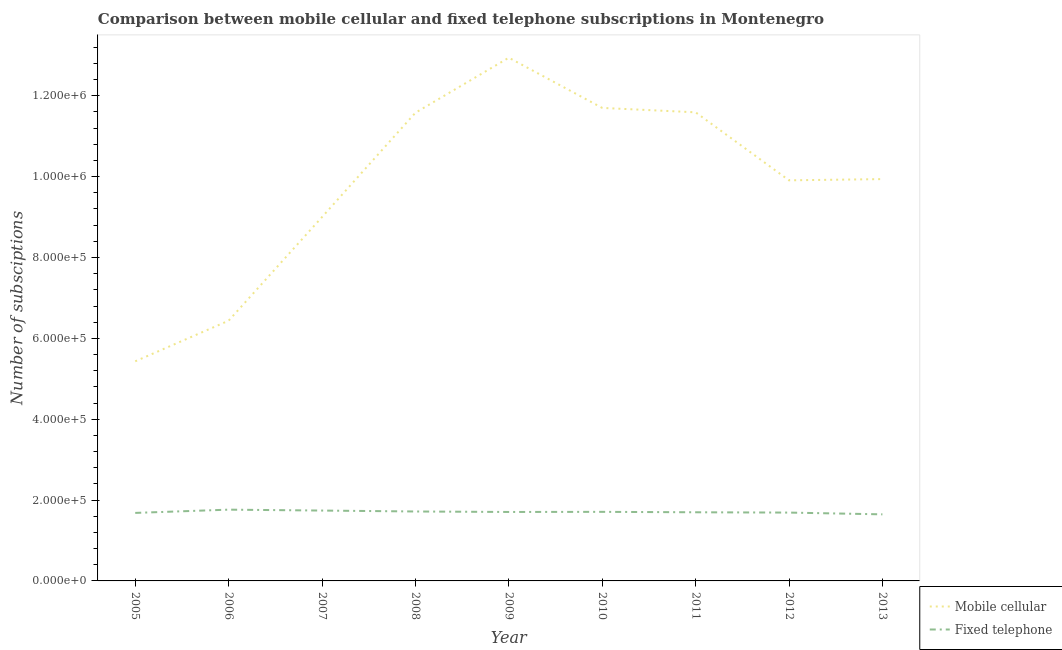What is the number of mobile cellular subscriptions in 2009?
Your answer should be very brief. 1.29e+06. Across all years, what is the maximum number of mobile cellular subscriptions?
Provide a short and direct response. 1.29e+06. Across all years, what is the minimum number of fixed telephone subscriptions?
Give a very brief answer. 1.65e+05. In which year was the number of mobile cellular subscriptions minimum?
Your answer should be very brief. 2005. What is the total number of fixed telephone subscriptions in the graph?
Provide a succinct answer. 1.54e+06. What is the difference between the number of fixed telephone subscriptions in 2006 and that in 2012?
Provide a succinct answer. 7257. What is the difference between the number of fixed telephone subscriptions in 2006 and the number of mobile cellular subscriptions in 2005?
Offer a very short reply. -3.67e+05. What is the average number of fixed telephone subscriptions per year?
Ensure brevity in your answer.  1.71e+05. In the year 2013, what is the difference between the number of fixed telephone subscriptions and number of mobile cellular subscriptions?
Give a very brief answer. -8.29e+05. What is the ratio of the number of fixed telephone subscriptions in 2005 to that in 2013?
Keep it short and to the point. 1.02. Is the number of mobile cellular subscriptions in 2005 less than that in 2007?
Keep it short and to the point. Yes. What is the difference between the highest and the second highest number of mobile cellular subscriptions?
Provide a succinct answer. 1.24e+05. What is the difference between the highest and the lowest number of fixed telephone subscriptions?
Give a very brief answer. 1.16e+04. In how many years, is the number of mobile cellular subscriptions greater than the average number of mobile cellular subscriptions taken over all years?
Ensure brevity in your answer.  6. Is the sum of the number of fixed telephone subscriptions in 2006 and 2009 greater than the maximum number of mobile cellular subscriptions across all years?
Make the answer very short. No. Does the number of mobile cellular subscriptions monotonically increase over the years?
Offer a terse response. No. Is the number of mobile cellular subscriptions strictly less than the number of fixed telephone subscriptions over the years?
Provide a short and direct response. No. How many years are there in the graph?
Your response must be concise. 9. Are the values on the major ticks of Y-axis written in scientific E-notation?
Offer a very short reply. Yes. Does the graph contain grids?
Make the answer very short. No. Where does the legend appear in the graph?
Ensure brevity in your answer.  Bottom right. How are the legend labels stacked?
Offer a terse response. Vertical. What is the title of the graph?
Provide a succinct answer. Comparison between mobile cellular and fixed telephone subscriptions in Montenegro. Does "Overweight" appear as one of the legend labels in the graph?
Provide a succinct answer. No. What is the label or title of the X-axis?
Offer a terse response. Year. What is the label or title of the Y-axis?
Keep it short and to the point. Number of subsciptions. What is the Number of subsciptions of Mobile cellular in 2005?
Provide a succinct answer. 5.43e+05. What is the Number of subsciptions of Fixed telephone in 2005?
Make the answer very short. 1.68e+05. What is the Number of subsciptions of Mobile cellular in 2006?
Offer a terse response. 6.44e+05. What is the Number of subsciptions in Fixed telephone in 2006?
Keep it short and to the point. 1.76e+05. What is the Number of subsciptions of Mobile cellular in 2007?
Provide a short and direct response. 9.00e+05. What is the Number of subsciptions of Fixed telephone in 2007?
Ensure brevity in your answer.  1.74e+05. What is the Number of subsciptions in Mobile cellular in 2008?
Your response must be concise. 1.16e+06. What is the Number of subsciptions of Fixed telephone in 2008?
Your response must be concise. 1.72e+05. What is the Number of subsciptions of Mobile cellular in 2009?
Give a very brief answer. 1.29e+06. What is the Number of subsciptions of Fixed telephone in 2009?
Make the answer very short. 1.71e+05. What is the Number of subsciptions in Mobile cellular in 2010?
Provide a succinct answer. 1.17e+06. What is the Number of subsciptions in Fixed telephone in 2010?
Offer a very short reply. 1.71e+05. What is the Number of subsciptions in Mobile cellular in 2011?
Offer a very short reply. 1.16e+06. What is the Number of subsciptions of Fixed telephone in 2011?
Your answer should be very brief. 1.70e+05. What is the Number of subsciptions in Mobile cellular in 2012?
Ensure brevity in your answer.  9.91e+05. What is the Number of subsciptions of Fixed telephone in 2012?
Your answer should be compact. 1.69e+05. What is the Number of subsciptions in Mobile cellular in 2013?
Provide a short and direct response. 9.94e+05. What is the Number of subsciptions of Fixed telephone in 2013?
Your answer should be compact. 1.65e+05. Across all years, what is the maximum Number of subsciptions of Mobile cellular?
Provide a short and direct response. 1.29e+06. Across all years, what is the maximum Number of subsciptions of Fixed telephone?
Keep it short and to the point. 1.76e+05. Across all years, what is the minimum Number of subsciptions of Mobile cellular?
Provide a succinct answer. 5.43e+05. Across all years, what is the minimum Number of subsciptions in Fixed telephone?
Offer a very short reply. 1.65e+05. What is the total Number of subsciptions of Mobile cellular in the graph?
Ensure brevity in your answer.  8.85e+06. What is the total Number of subsciptions of Fixed telephone in the graph?
Offer a very short reply. 1.54e+06. What is the difference between the Number of subsciptions of Mobile cellular in 2005 and that in 2006?
Your answer should be compact. -1.00e+05. What is the difference between the Number of subsciptions of Fixed telephone in 2005 and that in 2006?
Offer a terse response. -8056. What is the difference between the Number of subsciptions in Mobile cellular in 2005 and that in 2007?
Offer a terse response. -3.57e+05. What is the difference between the Number of subsciptions in Fixed telephone in 2005 and that in 2007?
Offer a terse response. -5813. What is the difference between the Number of subsciptions in Mobile cellular in 2005 and that in 2008?
Offer a terse response. -6.15e+05. What is the difference between the Number of subsciptions of Fixed telephone in 2005 and that in 2008?
Offer a terse response. -3516. What is the difference between the Number of subsciptions in Mobile cellular in 2005 and that in 2009?
Offer a very short reply. -7.51e+05. What is the difference between the Number of subsciptions in Fixed telephone in 2005 and that in 2009?
Make the answer very short. -2320. What is the difference between the Number of subsciptions of Mobile cellular in 2005 and that in 2010?
Keep it short and to the point. -6.27e+05. What is the difference between the Number of subsciptions of Fixed telephone in 2005 and that in 2010?
Offer a terse response. -2623. What is the difference between the Number of subsciptions in Mobile cellular in 2005 and that in 2011?
Your answer should be very brief. -6.16e+05. What is the difference between the Number of subsciptions in Fixed telephone in 2005 and that in 2011?
Your answer should be compact. -1570. What is the difference between the Number of subsciptions of Mobile cellular in 2005 and that in 2012?
Keep it short and to the point. -4.48e+05. What is the difference between the Number of subsciptions of Fixed telephone in 2005 and that in 2012?
Make the answer very short. -799. What is the difference between the Number of subsciptions of Mobile cellular in 2005 and that in 2013?
Ensure brevity in your answer.  -4.51e+05. What is the difference between the Number of subsciptions of Fixed telephone in 2005 and that in 2013?
Your answer should be compact. 3562. What is the difference between the Number of subsciptions of Mobile cellular in 2006 and that in 2007?
Provide a short and direct response. -2.56e+05. What is the difference between the Number of subsciptions in Fixed telephone in 2006 and that in 2007?
Make the answer very short. 2243. What is the difference between the Number of subsciptions of Mobile cellular in 2006 and that in 2008?
Offer a very short reply. -5.14e+05. What is the difference between the Number of subsciptions in Fixed telephone in 2006 and that in 2008?
Offer a very short reply. 4540. What is the difference between the Number of subsciptions of Mobile cellular in 2006 and that in 2009?
Provide a succinct answer. -6.50e+05. What is the difference between the Number of subsciptions of Fixed telephone in 2006 and that in 2009?
Offer a terse response. 5736. What is the difference between the Number of subsciptions of Mobile cellular in 2006 and that in 2010?
Provide a succinct answer. -5.26e+05. What is the difference between the Number of subsciptions of Fixed telephone in 2006 and that in 2010?
Provide a short and direct response. 5433. What is the difference between the Number of subsciptions in Mobile cellular in 2006 and that in 2011?
Ensure brevity in your answer.  -5.15e+05. What is the difference between the Number of subsciptions of Fixed telephone in 2006 and that in 2011?
Make the answer very short. 6486. What is the difference between the Number of subsciptions in Mobile cellular in 2006 and that in 2012?
Provide a short and direct response. -3.47e+05. What is the difference between the Number of subsciptions in Fixed telephone in 2006 and that in 2012?
Ensure brevity in your answer.  7257. What is the difference between the Number of subsciptions of Mobile cellular in 2006 and that in 2013?
Make the answer very short. -3.50e+05. What is the difference between the Number of subsciptions of Fixed telephone in 2006 and that in 2013?
Provide a succinct answer. 1.16e+04. What is the difference between the Number of subsciptions of Mobile cellular in 2007 and that in 2008?
Offer a very short reply. -2.58e+05. What is the difference between the Number of subsciptions of Fixed telephone in 2007 and that in 2008?
Offer a terse response. 2297. What is the difference between the Number of subsciptions in Mobile cellular in 2007 and that in 2009?
Your answer should be very brief. -3.94e+05. What is the difference between the Number of subsciptions in Fixed telephone in 2007 and that in 2009?
Your answer should be very brief. 3493. What is the difference between the Number of subsciptions in Fixed telephone in 2007 and that in 2010?
Your answer should be very brief. 3190. What is the difference between the Number of subsciptions in Mobile cellular in 2007 and that in 2011?
Provide a succinct answer. -2.59e+05. What is the difference between the Number of subsciptions of Fixed telephone in 2007 and that in 2011?
Provide a succinct answer. 4243. What is the difference between the Number of subsciptions of Mobile cellular in 2007 and that in 2012?
Provide a succinct answer. -9.09e+04. What is the difference between the Number of subsciptions of Fixed telephone in 2007 and that in 2012?
Give a very brief answer. 5014. What is the difference between the Number of subsciptions of Mobile cellular in 2007 and that in 2013?
Your response must be concise. -9.39e+04. What is the difference between the Number of subsciptions in Fixed telephone in 2007 and that in 2013?
Provide a succinct answer. 9375. What is the difference between the Number of subsciptions of Mobile cellular in 2008 and that in 2009?
Provide a short and direct response. -1.36e+05. What is the difference between the Number of subsciptions in Fixed telephone in 2008 and that in 2009?
Offer a very short reply. 1196. What is the difference between the Number of subsciptions in Mobile cellular in 2008 and that in 2010?
Make the answer very short. -1.20e+04. What is the difference between the Number of subsciptions in Fixed telephone in 2008 and that in 2010?
Your answer should be compact. 893. What is the difference between the Number of subsciptions in Mobile cellular in 2008 and that in 2011?
Give a very brief answer. -1080. What is the difference between the Number of subsciptions in Fixed telephone in 2008 and that in 2011?
Ensure brevity in your answer.  1946. What is the difference between the Number of subsciptions in Mobile cellular in 2008 and that in 2012?
Offer a terse response. 1.67e+05. What is the difference between the Number of subsciptions in Fixed telephone in 2008 and that in 2012?
Provide a short and direct response. 2717. What is the difference between the Number of subsciptions of Mobile cellular in 2008 and that in 2013?
Provide a succinct answer. 1.64e+05. What is the difference between the Number of subsciptions in Fixed telephone in 2008 and that in 2013?
Your response must be concise. 7078. What is the difference between the Number of subsciptions in Mobile cellular in 2009 and that in 2010?
Your answer should be compact. 1.24e+05. What is the difference between the Number of subsciptions of Fixed telephone in 2009 and that in 2010?
Offer a terse response. -303. What is the difference between the Number of subsciptions in Mobile cellular in 2009 and that in 2011?
Give a very brief answer. 1.35e+05. What is the difference between the Number of subsciptions of Fixed telephone in 2009 and that in 2011?
Make the answer very short. 750. What is the difference between the Number of subsciptions in Mobile cellular in 2009 and that in 2012?
Your response must be concise. 3.03e+05. What is the difference between the Number of subsciptions of Fixed telephone in 2009 and that in 2012?
Provide a succinct answer. 1521. What is the difference between the Number of subsciptions of Mobile cellular in 2009 and that in 2013?
Keep it short and to the point. 3.00e+05. What is the difference between the Number of subsciptions of Fixed telephone in 2009 and that in 2013?
Make the answer very short. 5882. What is the difference between the Number of subsciptions of Mobile cellular in 2010 and that in 2011?
Your answer should be very brief. 1.09e+04. What is the difference between the Number of subsciptions in Fixed telephone in 2010 and that in 2011?
Offer a terse response. 1053. What is the difference between the Number of subsciptions of Mobile cellular in 2010 and that in 2012?
Your answer should be compact. 1.79e+05. What is the difference between the Number of subsciptions in Fixed telephone in 2010 and that in 2012?
Your response must be concise. 1824. What is the difference between the Number of subsciptions in Mobile cellular in 2010 and that in 2013?
Provide a succinct answer. 1.76e+05. What is the difference between the Number of subsciptions of Fixed telephone in 2010 and that in 2013?
Keep it short and to the point. 6185. What is the difference between the Number of subsciptions in Mobile cellular in 2011 and that in 2012?
Offer a very short reply. 1.68e+05. What is the difference between the Number of subsciptions of Fixed telephone in 2011 and that in 2012?
Provide a short and direct response. 771. What is the difference between the Number of subsciptions of Mobile cellular in 2011 and that in 2013?
Ensure brevity in your answer.  1.65e+05. What is the difference between the Number of subsciptions of Fixed telephone in 2011 and that in 2013?
Offer a very short reply. 5132. What is the difference between the Number of subsciptions of Mobile cellular in 2012 and that in 2013?
Provide a short and direct response. -3033. What is the difference between the Number of subsciptions in Fixed telephone in 2012 and that in 2013?
Your answer should be compact. 4361. What is the difference between the Number of subsciptions in Mobile cellular in 2005 and the Number of subsciptions in Fixed telephone in 2006?
Provide a short and direct response. 3.67e+05. What is the difference between the Number of subsciptions of Mobile cellular in 2005 and the Number of subsciptions of Fixed telephone in 2007?
Your response must be concise. 3.69e+05. What is the difference between the Number of subsciptions of Mobile cellular in 2005 and the Number of subsciptions of Fixed telephone in 2008?
Offer a very short reply. 3.71e+05. What is the difference between the Number of subsciptions of Mobile cellular in 2005 and the Number of subsciptions of Fixed telephone in 2009?
Give a very brief answer. 3.73e+05. What is the difference between the Number of subsciptions of Mobile cellular in 2005 and the Number of subsciptions of Fixed telephone in 2010?
Offer a very short reply. 3.72e+05. What is the difference between the Number of subsciptions of Mobile cellular in 2005 and the Number of subsciptions of Fixed telephone in 2011?
Ensure brevity in your answer.  3.73e+05. What is the difference between the Number of subsciptions in Mobile cellular in 2005 and the Number of subsciptions in Fixed telephone in 2012?
Your answer should be very brief. 3.74e+05. What is the difference between the Number of subsciptions of Mobile cellular in 2005 and the Number of subsciptions of Fixed telephone in 2013?
Offer a terse response. 3.79e+05. What is the difference between the Number of subsciptions in Mobile cellular in 2006 and the Number of subsciptions in Fixed telephone in 2007?
Keep it short and to the point. 4.70e+05. What is the difference between the Number of subsciptions in Mobile cellular in 2006 and the Number of subsciptions in Fixed telephone in 2008?
Make the answer very short. 4.72e+05. What is the difference between the Number of subsciptions of Mobile cellular in 2006 and the Number of subsciptions of Fixed telephone in 2009?
Your answer should be compact. 4.73e+05. What is the difference between the Number of subsciptions of Mobile cellular in 2006 and the Number of subsciptions of Fixed telephone in 2010?
Offer a very short reply. 4.73e+05. What is the difference between the Number of subsciptions of Mobile cellular in 2006 and the Number of subsciptions of Fixed telephone in 2011?
Offer a very short reply. 4.74e+05. What is the difference between the Number of subsciptions in Mobile cellular in 2006 and the Number of subsciptions in Fixed telephone in 2012?
Ensure brevity in your answer.  4.75e+05. What is the difference between the Number of subsciptions of Mobile cellular in 2006 and the Number of subsciptions of Fixed telephone in 2013?
Your answer should be very brief. 4.79e+05. What is the difference between the Number of subsciptions of Mobile cellular in 2007 and the Number of subsciptions of Fixed telephone in 2008?
Ensure brevity in your answer.  7.28e+05. What is the difference between the Number of subsciptions of Mobile cellular in 2007 and the Number of subsciptions of Fixed telephone in 2009?
Keep it short and to the point. 7.29e+05. What is the difference between the Number of subsciptions in Mobile cellular in 2007 and the Number of subsciptions in Fixed telephone in 2010?
Give a very brief answer. 7.29e+05. What is the difference between the Number of subsciptions of Mobile cellular in 2007 and the Number of subsciptions of Fixed telephone in 2011?
Ensure brevity in your answer.  7.30e+05. What is the difference between the Number of subsciptions in Mobile cellular in 2007 and the Number of subsciptions in Fixed telephone in 2012?
Your answer should be very brief. 7.31e+05. What is the difference between the Number of subsciptions of Mobile cellular in 2007 and the Number of subsciptions of Fixed telephone in 2013?
Your answer should be compact. 7.35e+05. What is the difference between the Number of subsciptions of Mobile cellular in 2008 and the Number of subsciptions of Fixed telephone in 2009?
Offer a terse response. 9.87e+05. What is the difference between the Number of subsciptions of Mobile cellular in 2008 and the Number of subsciptions of Fixed telephone in 2010?
Offer a very short reply. 9.87e+05. What is the difference between the Number of subsciptions in Mobile cellular in 2008 and the Number of subsciptions in Fixed telephone in 2011?
Your answer should be very brief. 9.88e+05. What is the difference between the Number of subsciptions of Mobile cellular in 2008 and the Number of subsciptions of Fixed telephone in 2012?
Keep it short and to the point. 9.89e+05. What is the difference between the Number of subsciptions of Mobile cellular in 2008 and the Number of subsciptions of Fixed telephone in 2013?
Offer a terse response. 9.93e+05. What is the difference between the Number of subsciptions in Mobile cellular in 2009 and the Number of subsciptions in Fixed telephone in 2010?
Offer a very short reply. 1.12e+06. What is the difference between the Number of subsciptions in Mobile cellular in 2009 and the Number of subsciptions in Fixed telephone in 2011?
Your response must be concise. 1.12e+06. What is the difference between the Number of subsciptions of Mobile cellular in 2009 and the Number of subsciptions of Fixed telephone in 2012?
Your response must be concise. 1.13e+06. What is the difference between the Number of subsciptions in Mobile cellular in 2009 and the Number of subsciptions in Fixed telephone in 2013?
Provide a short and direct response. 1.13e+06. What is the difference between the Number of subsciptions in Mobile cellular in 2010 and the Number of subsciptions in Fixed telephone in 2011?
Ensure brevity in your answer.  1.00e+06. What is the difference between the Number of subsciptions of Mobile cellular in 2010 and the Number of subsciptions of Fixed telephone in 2012?
Your response must be concise. 1.00e+06. What is the difference between the Number of subsciptions of Mobile cellular in 2010 and the Number of subsciptions of Fixed telephone in 2013?
Your answer should be very brief. 1.01e+06. What is the difference between the Number of subsciptions of Mobile cellular in 2011 and the Number of subsciptions of Fixed telephone in 2012?
Your answer should be compact. 9.90e+05. What is the difference between the Number of subsciptions of Mobile cellular in 2011 and the Number of subsciptions of Fixed telephone in 2013?
Keep it short and to the point. 9.94e+05. What is the difference between the Number of subsciptions in Mobile cellular in 2012 and the Number of subsciptions in Fixed telephone in 2013?
Provide a succinct answer. 8.26e+05. What is the average Number of subsciptions of Mobile cellular per year?
Keep it short and to the point. 9.84e+05. What is the average Number of subsciptions in Fixed telephone per year?
Your answer should be very brief. 1.71e+05. In the year 2005, what is the difference between the Number of subsciptions in Mobile cellular and Number of subsciptions in Fixed telephone?
Your answer should be compact. 3.75e+05. In the year 2006, what is the difference between the Number of subsciptions in Mobile cellular and Number of subsciptions in Fixed telephone?
Ensure brevity in your answer.  4.67e+05. In the year 2007, what is the difference between the Number of subsciptions of Mobile cellular and Number of subsciptions of Fixed telephone?
Your answer should be compact. 7.26e+05. In the year 2008, what is the difference between the Number of subsciptions of Mobile cellular and Number of subsciptions of Fixed telephone?
Provide a short and direct response. 9.86e+05. In the year 2009, what is the difference between the Number of subsciptions of Mobile cellular and Number of subsciptions of Fixed telephone?
Your answer should be very brief. 1.12e+06. In the year 2010, what is the difference between the Number of subsciptions in Mobile cellular and Number of subsciptions in Fixed telephone?
Provide a succinct answer. 9.99e+05. In the year 2011, what is the difference between the Number of subsciptions in Mobile cellular and Number of subsciptions in Fixed telephone?
Keep it short and to the point. 9.89e+05. In the year 2012, what is the difference between the Number of subsciptions in Mobile cellular and Number of subsciptions in Fixed telephone?
Offer a very short reply. 8.22e+05. In the year 2013, what is the difference between the Number of subsciptions of Mobile cellular and Number of subsciptions of Fixed telephone?
Offer a very short reply. 8.29e+05. What is the ratio of the Number of subsciptions of Mobile cellular in 2005 to that in 2006?
Make the answer very short. 0.84. What is the ratio of the Number of subsciptions in Fixed telephone in 2005 to that in 2006?
Provide a succinct answer. 0.95. What is the ratio of the Number of subsciptions of Mobile cellular in 2005 to that in 2007?
Offer a very short reply. 0.6. What is the ratio of the Number of subsciptions in Fixed telephone in 2005 to that in 2007?
Your response must be concise. 0.97. What is the ratio of the Number of subsciptions of Mobile cellular in 2005 to that in 2008?
Provide a short and direct response. 0.47. What is the ratio of the Number of subsciptions of Fixed telephone in 2005 to that in 2008?
Your answer should be very brief. 0.98. What is the ratio of the Number of subsciptions in Mobile cellular in 2005 to that in 2009?
Your answer should be compact. 0.42. What is the ratio of the Number of subsciptions of Fixed telephone in 2005 to that in 2009?
Offer a terse response. 0.99. What is the ratio of the Number of subsciptions in Mobile cellular in 2005 to that in 2010?
Provide a short and direct response. 0.46. What is the ratio of the Number of subsciptions in Fixed telephone in 2005 to that in 2010?
Make the answer very short. 0.98. What is the ratio of the Number of subsciptions of Mobile cellular in 2005 to that in 2011?
Ensure brevity in your answer.  0.47. What is the ratio of the Number of subsciptions of Fixed telephone in 2005 to that in 2011?
Provide a succinct answer. 0.99. What is the ratio of the Number of subsciptions in Mobile cellular in 2005 to that in 2012?
Offer a terse response. 0.55. What is the ratio of the Number of subsciptions of Fixed telephone in 2005 to that in 2012?
Your answer should be very brief. 1. What is the ratio of the Number of subsciptions of Mobile cellular in 2005 to that in 2013?
Make the answer very short. 0.55. What is the ratio of the Number of subsciptions of Fixed telephone in 2005 to that in 2013?
Provide a succinct answer. 1.02. What is the ratio of the Number of subsciptions of Mobile cellular in 2006 to that in 2007?
Your answer should be very brief. 0.72. What is the ratio of the Number of subsciptions in Fixed telephone in 2006 to that in 2007?
Provide a succinct answer. 1.01. What is the ratio of the Number of subsciptions in Mobile cellular in 2006 to that in 2008?
Your answer should be very brief. 0.56. What is the ratio of the Number of subsciptions of Fixed telephone in 2006 to that in 2008?
Keep it short and to the point. 1.03. What is the ratio of the Number of subsciptions in Mobile cellular in 2006 to that in 2009?
Provide a short and direct response. 0.5. What is the ratio of the Number of subsciptions in Fixed telephone in 2006 to that in 2009?
Keep it short and to the point. 1.03. What is the ratio of the Number of subsciptions in Mobile cellular in 2006 to that in 2010?
Your answer should be very brief. 0.55. What is the ratio of the Number of subsciptions in Fixed telephone in 2006 to that in 2010?
Make the answer very short. 1.03. What is the ratio of the Number of subsciptions in Mobile cellular in 2006 to that in 2011?
Offer a very short reply. 0.56. What is the ratio of the Number of subsciptions in Fixed telephone in 2006 to that in 2011?
Ensure brevity in your answer.  1.04. What is the ratio of the Number of subsciptions of Mobile cellular in 2006 to that in 2012?
Your answer should be compact. 0.65. What is the ratio of the Number of subsciptions of Fixed telephone in 2006 to that in 2012?
Offer a terse response. 1.04. What is the ratio of the Number of subsciptions in Mobile cellular in 2006 to that in 2013?
Your answer should be very brief. 0.65. What is the ratio of the Number of subsciptions of Fixed telephone in 2006 to that in 2013?
Your response must be concise. 1.07. What is the ratio of the Number of subsciptions in Mobile cellular in 2007 to that in 2008?
Your answer should be very brief. 0.78. What is the ratio of the Number of subsciptions of Fixed telephone in 2007 to that in 2008?
Your answer should be compact. 1.01. What is the ratio of the Number of subsciptions in Mobile cellular in 2007 to that in 2009?
Your answer should be very brief. 0.7. What is the ratio of the Number of subsciptions of Fixed telephone in 2007 to that in 2009?
Ensure brevity in your answer.  1.02. What is the ratio of the Number of subsciptions of Mobile cellular in 2007 to that in 2010?
Offer a terse response. 0.77. What is the ratio of the Number of subsciptions of Fixed telephone in 2007 to that in 2010?
Provide a succinct answer. 1.02. What is the ratio of the Number of subsciptions in Mobile cellular in 2007 to that in 2011?
Make the answer very short. 0.78. What is the ratio of the Number of subsciptions in Mobile cellular in 2007 to that in 2012?
Make the answer very short. 0.91. What is the ratio of the Number of subsciptions of Fixed telephone in 2007 to that in 2012?
Offer a very short reply. 1.03. What is the ratio of the Number of subsciptions of Mobile cellular in 2007 to that in 2013?
Provide a succinct answer. 0.91. What is the ratio of the Number of subsciptions of Fixed telephone in 2007 to that in 2013?
Give a very brief answer. 1.06. What is the ratio of the Number of subsciptions of Mobile cellular in 2008 to that in 2009?
Your answer should be very brief. 0.89. What is the ratio of the Number of subsciptions of Mobile cellular in 2008 to that in 2011?
Ensure brevity in your answer.  1. What is the ratio of the Number of subsciptions in Fixed telephone in 2008 to that in 2011?
Keep it short and to the point. 1.01. What is the ratio of the Number of subsciptions of Mobile cellular in 2008 to that in 2012?
Keep it short and to the point. 1.17. What is the ratio of the Number of subsciptions in Fixed telephone in 2008 to that in 2012?
Provide a short and direct response. 1.02. What is the ratio of the Number of subsciptions in Mobile cellular in 2008 to that in 2013?
Your answer should be compact. 1.17. What is the ratio of the Number of subsciptions of Fixed telephone in 2008 to that in 2013?
Your response must be concise. 1.04. What is the ratio of the Number of subsciptions of Mobile cellular in 2009 to that in 2010?
Your response must be concise. 1.11. What is the ratio of the Number of subsciptions of Fixed telephone in 2009 to that in 2010?
Provide a short and direct response. 1. What is the ratio of the Number of subsciptions of Mobile cellular in 2009 to that in 2011?
Give a very brief answer. 1.12. What is the ratio of the Number of subsciptions in Mobile cellular in 2009 to that in 2012?
Ensure brevity in your answer.  1.31. What is the ratio of the Number of subsciptions in Fixed telephone in 2009 to that in 2012?
Keep it short and to the point. 1.01. What is the ratio of the Number of subsciptions in Mobile cellular in 2009 to that in 2013?
Your answer should be very brief. 1.3. What is the ratio of the Number of subsciptions of Fixed telephone in 2009 to that in 2013?
Keep it short and to the point. 1.04. What is the ratio of the Number of subsciptions in Mobile cellular in 2010 to that in 2011?
Ensure brevity in your answer.  1.01. What is the ratio of the Number of subsciptions in Fixed telephone in 2010 to that in 2011?
Your answer should be compact. 1.01. What is the ratio of the Number of subsciptions of Mobile cellular in 2010 to that in 2012?
Provide a succinct answer. 1.18. What is the ratio of the Number of subsciptions of Fixed telephone in 2010 to that in 2012?
Keep it short and to the point. 1.01. What is the ratio of the Number of subsciptions in Mobile cellular in 2010 to that in 2013?
Ensure brevity in your answer.  1.18. What is the ratio of the Number of subsciptions in Fixed telephone in 2010 to that in 2013?
Your response must be concise. 1.04. What is the ratio of the Number of subsciptions of Mobile cellular in 2011 to that in 2012?
Offer a terse response. 1.17. What is the ratio of the Number of subsciptions of Fixed telephone in 2011 to that in 2012?
Offer a terse response. 1. What is the ratio of the Number of subsciptions of Mobile cellular in 2011 to that in 2013?
Give a very brief answer. 1.17. What is the ratio of the Number of subsciptions of Fixed telephone in 2011 to that in 2013?
Make the answer very short. 1.03. What is the ratio of the Number of subsciptions in Mobile cellular in 2012 to that in 2013?
Offer a terse response. 1. What is the ratio of the Number of subsciptions of Fixed telephone in 2012 to that in 2013?
Offer a very short reply. 1.03. What is the difference between the highest and the second highest Number of subsciptions in Mobile cellular?
Make the answer very short. 1.24e+05. What is the difference between the highest and the second highest Number of subsciptions of Fixed telephone?
Make the answer very short. 2243. What is the difference between the highest and the lowest Number of subsciptions in Mobile cellular?
Your response must be concise. 7.51e+05. What is the difference between the highest and the lowest Number of subsciptions of Fixed telephone?
Provide a succinct answer. 1.16e+04. 